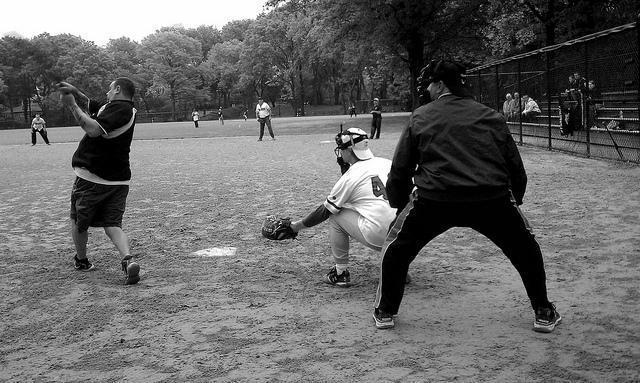How many people can be seen?
Give a very brief answer. 3. 